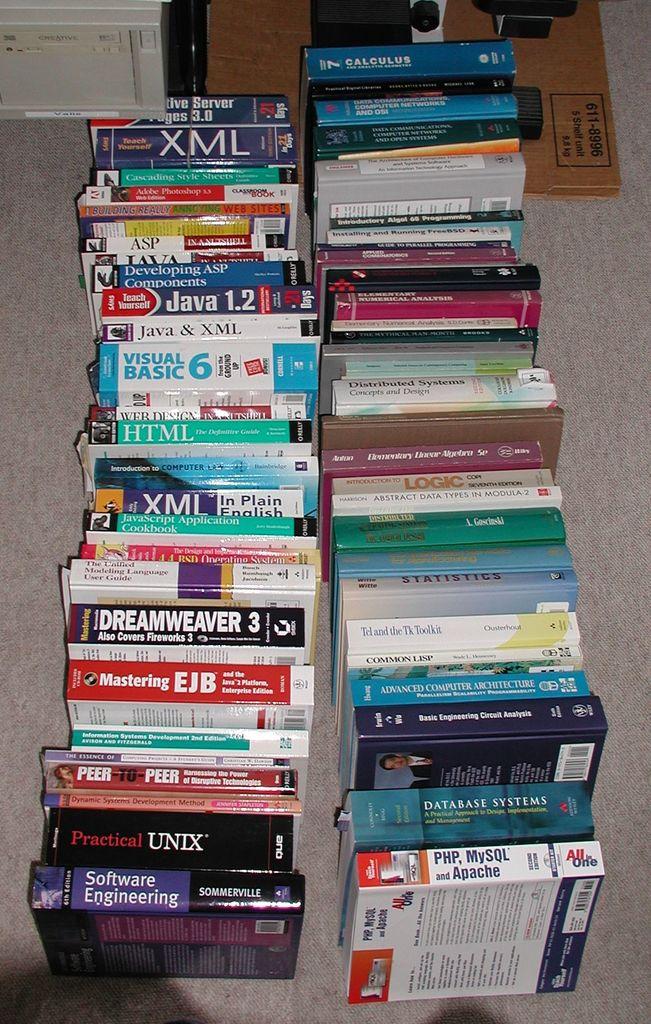What kind of engineering is the purple book about?
Offer a terse response. Software. What subject is the top textbook on the right about?
Provide a short and direct response. Calculus. 